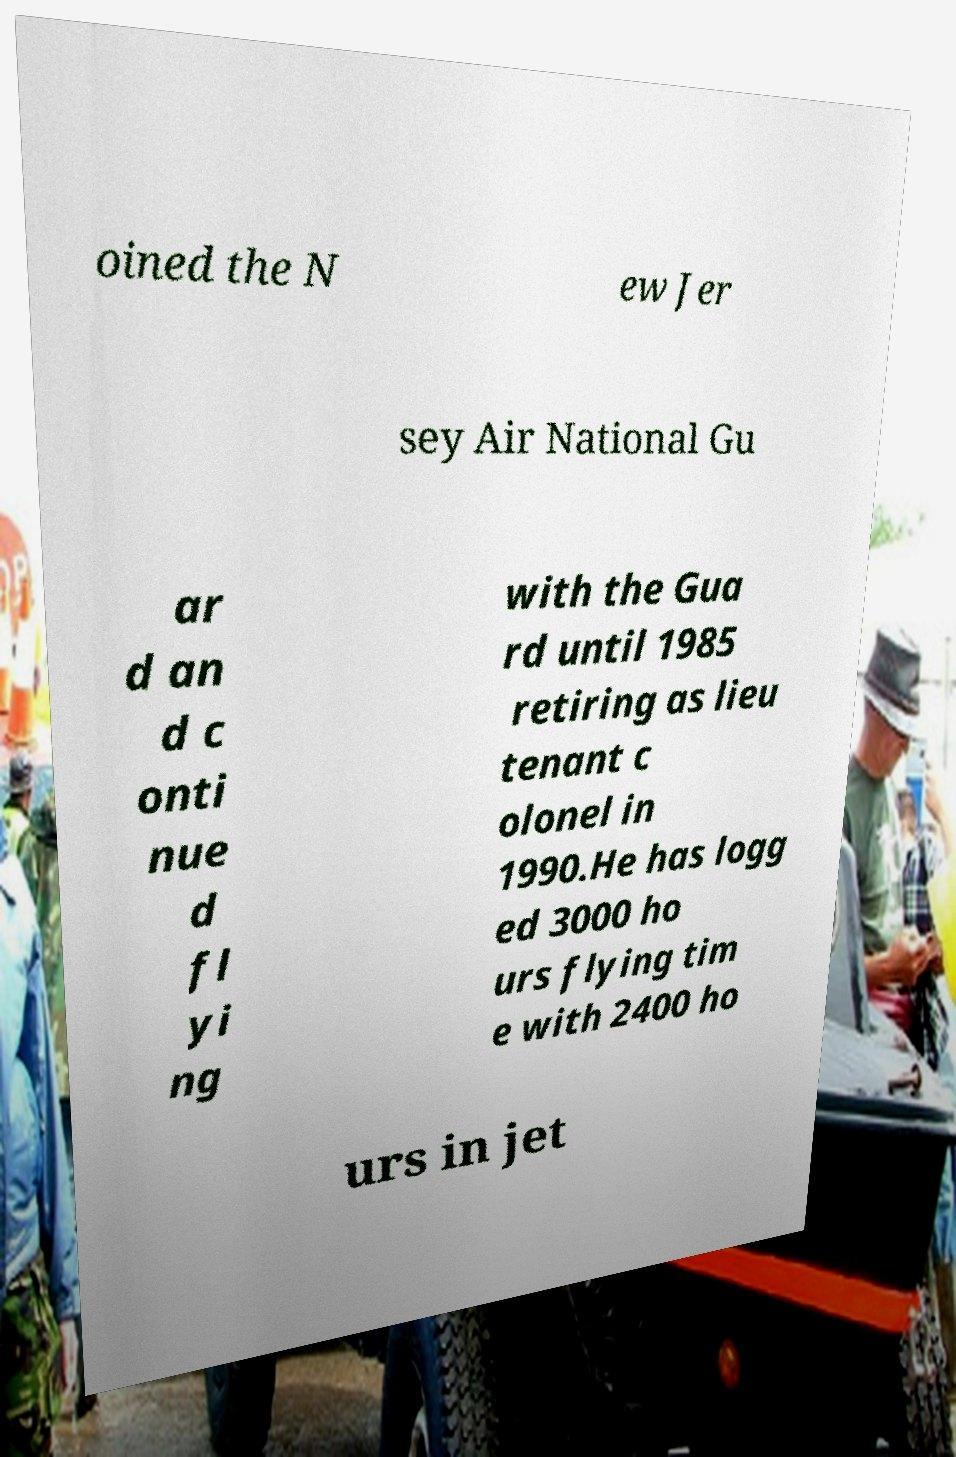I need the written content from this picture converted into text. Can you do that? oined the N ew Jer sey Air National Gu ar d an d c onti nue d fl yi ng with the Gua rd until 1985 retiring as lieu tenant c olonel in 1990.He has logg ed 3000 ho urs flying tim e with 2400 ho urs in jet 